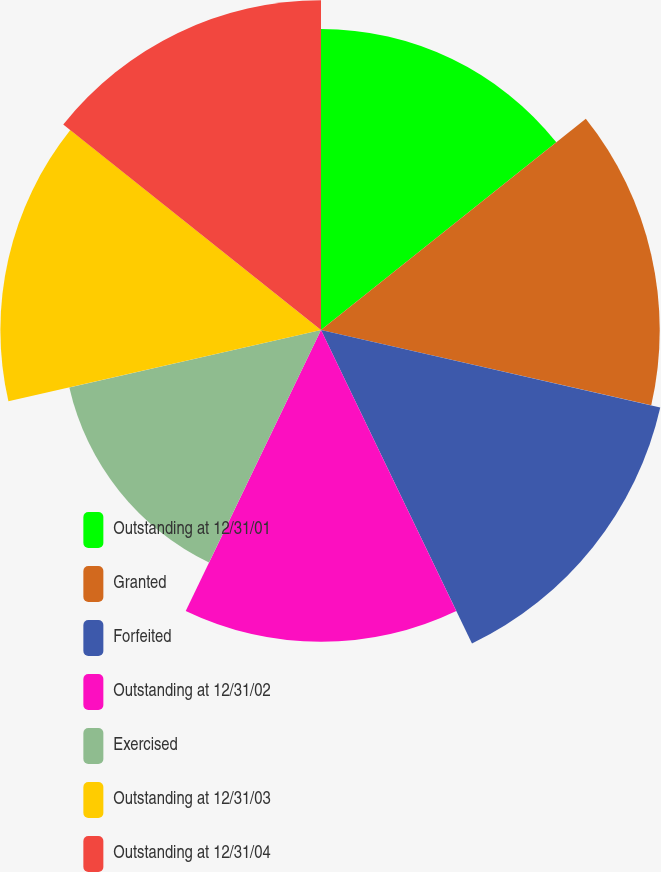<chart> <loc_0><loc_0><loc_500><loc_500><pie_chart><fcel>Outstanding at 12/31/01<fcel>Granted<fcel>Forfeited<fcel>Outstanding at 12/31/02<fcel>Exercised<fcel>Outstanding at 12/31/03<fcel>Outstanding at 12/31/04<nl><fcel>13.63%<fcel>15.34%<fcel>15.76%<fcel>14.12%<fcel>11.69%<fcel>14.52%<fcel>14.93%<nl></chart> 